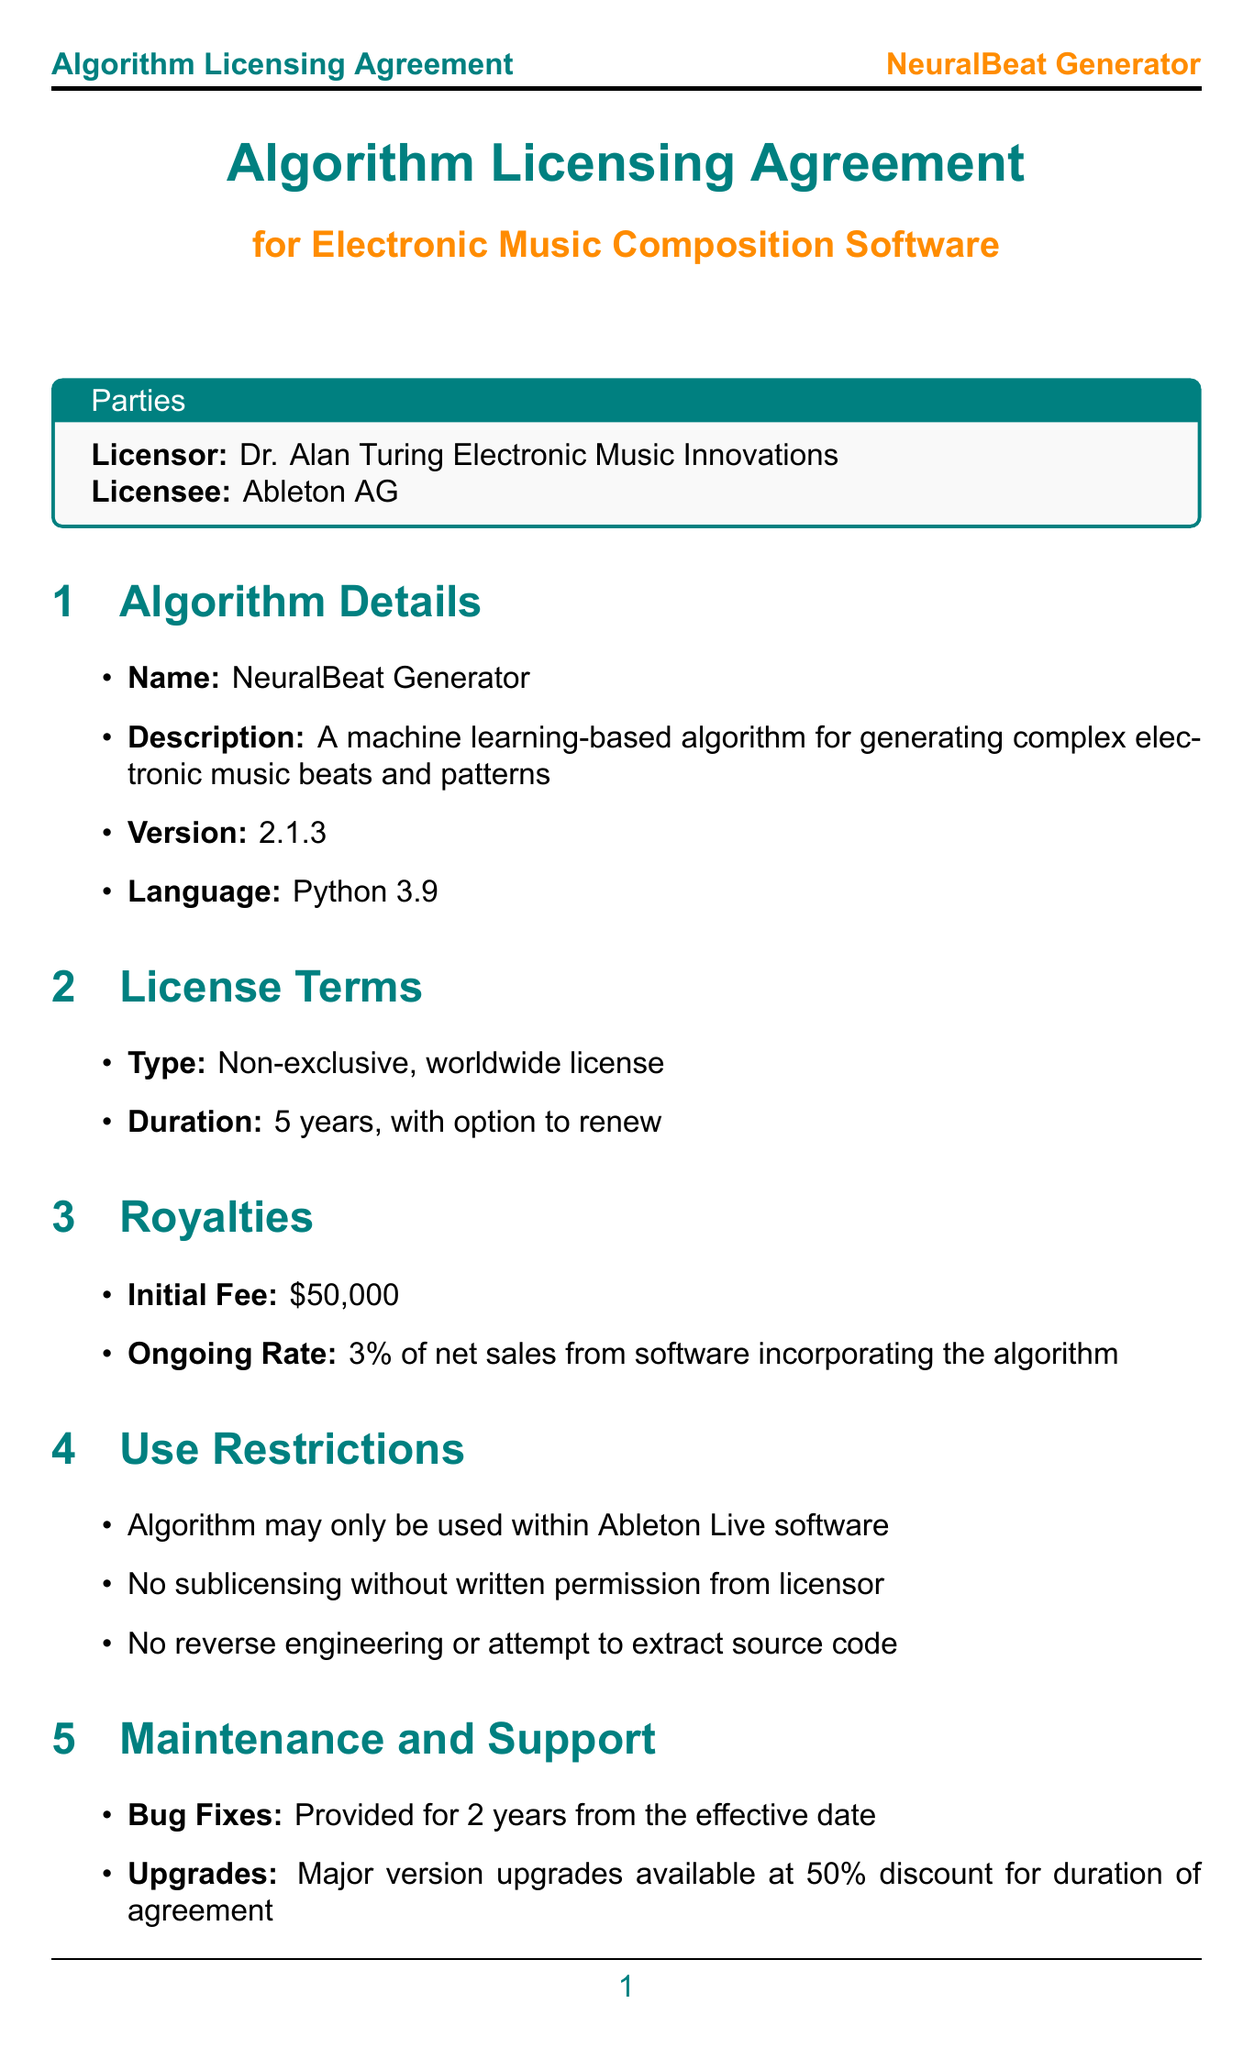What is the name of the algorithm? The name of the algorithm is explicitly stated in the document under algorithm details.
Answer: NeuralBeat Generator What is the initial fee for the license? The initial fee is listed in the royalties section of the document.
Answer: $50,000 What is the duration of the license agreement? The duration of the license agreement can be found in the license terms section.
Answer: 5 years, with option to renew What are the minimum system requirements for the algorithm? The minimum system requirements are specified under technical specifications in the document.
Answer: Intel Core i5 or equivalent, 8 GB RAM, 500 MB free disk space What is the governing law for disputes? The governing law is mentioned in the dispute resolution section of the document.
Answer: Laws of England and Wales What is required for sublicensing the algorithm? The conditions for sublicensing are described under use restrictions in the document.
Answer: Written permission from licensor How long are bug fixes provided after the effective date? The duration for which bug fixes are provided is stated in the maintenance and support section.
Answer: 2 years What kind of support is included in the integration section? The integration section details the level of support provided to the licensee.
Answer: 40 hours of remote consultation What is the frequency of audit rights? The audit rights frequency is discussed in the audit rights section of the document.
Answer: Once per year with 30 days notice 